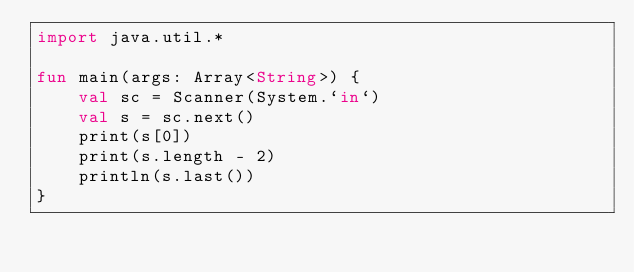Convert code to text. <code><loc_0><loc_0><loc_500><loc_500><_Kotlin_>import java.util.*

fun main(args: Array<String>) {
    val sc = Scanner(System.`in`)
    val s = sc.next()
    print(s[0])
    print(s.length - 2)
    println(s.last())
}
</code> 